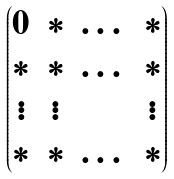<formula> <loc_0><loc_0><loc_500><loc_500>\begin{pmatrix} 0 & * & \dots & * \\ * & * & \dots & * \\ \vdots & \vdots & & \vdots \\ * & * & \dots & * \\ \end{pmatrix}</formula> 